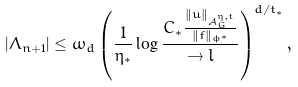<formula> <loc_0><loc_0><loc_500><loc_500>| \Lambda _ { n + 1 } | \leq \omega _ { d } \left ( \frac { 1 } { \eta _ { * } } \log \frac { C _ { * } \frac { \| u \| _ { \mathcal { A } _ { G } ^ { \eta , t } } } { \| f \| _ { \phi ^ { * } } } } { \to l } \right ) ^ { d / t _ { * } } ,</formula> 